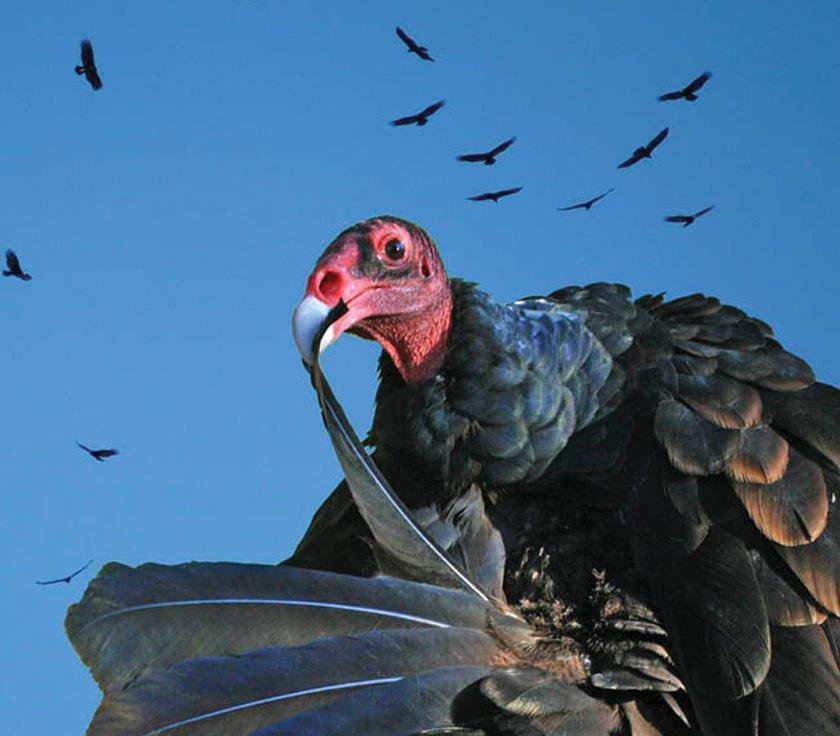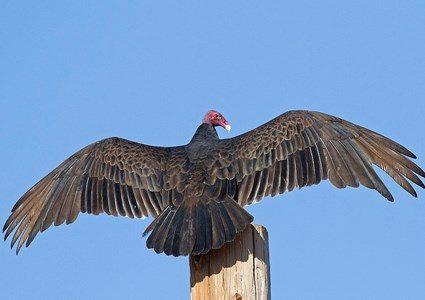The first image is the image on the left, the second image is the image on the right. Considering the images on both sides, is "A rear-facing vulture is perched on something wooden and has its wings spreading." valid? Answer yes or no. Yes. The first image is the image on the left, the second image is the image on the right. Assess this claim about the two images: "Two birds are close up, while 4 or more birds are flying high in the distance.". Correct or not? Answer yes or no. Yes. 